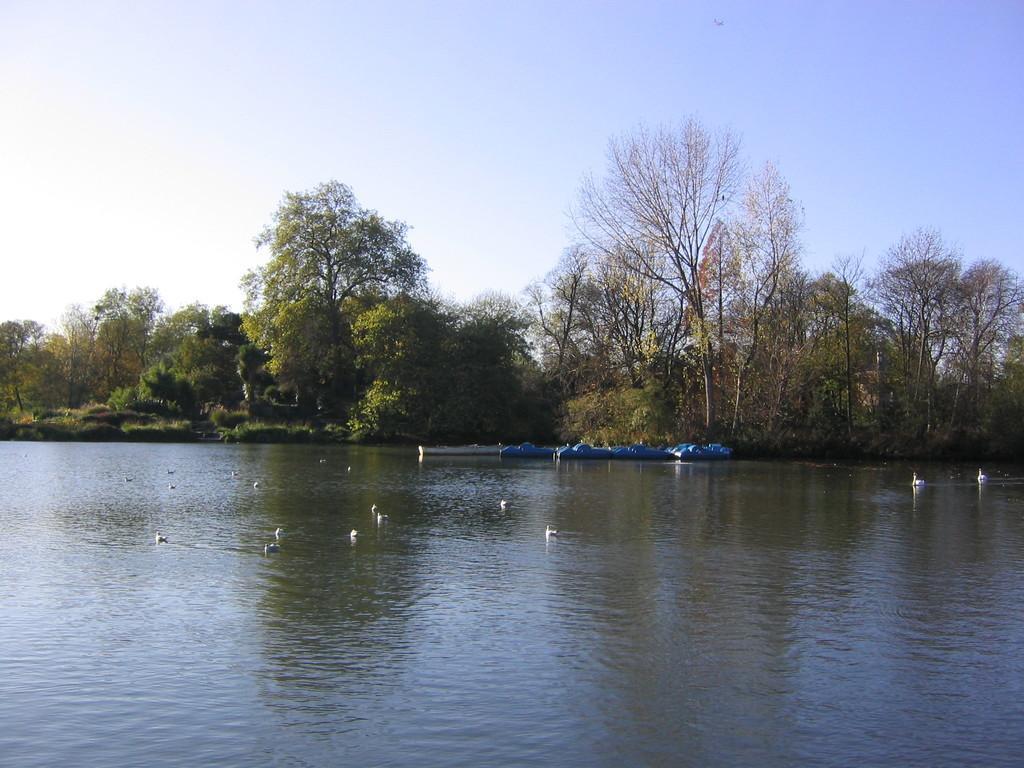In one or two sentences, can you explain what this image depicts? In this picture we can see few boats and birds on the water, in the background we can see few trees. 